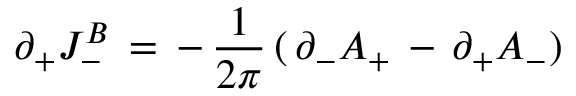<formula> <loc_0><loc_0><loc_500><loc_500>\partial _ { + } J _ { - } ^ { B } \, = \, - \, { \frac { 1 } { 2 \pi } } \, ( \, \partial _ { - } A _ { + } \, - \, \partial _ { + } A _ { - } )</formula> 